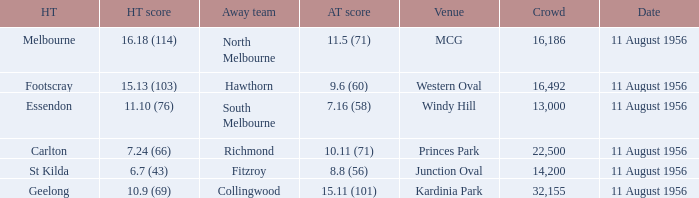Where did a home team score 10.9 (69)? Kardinia Park. 